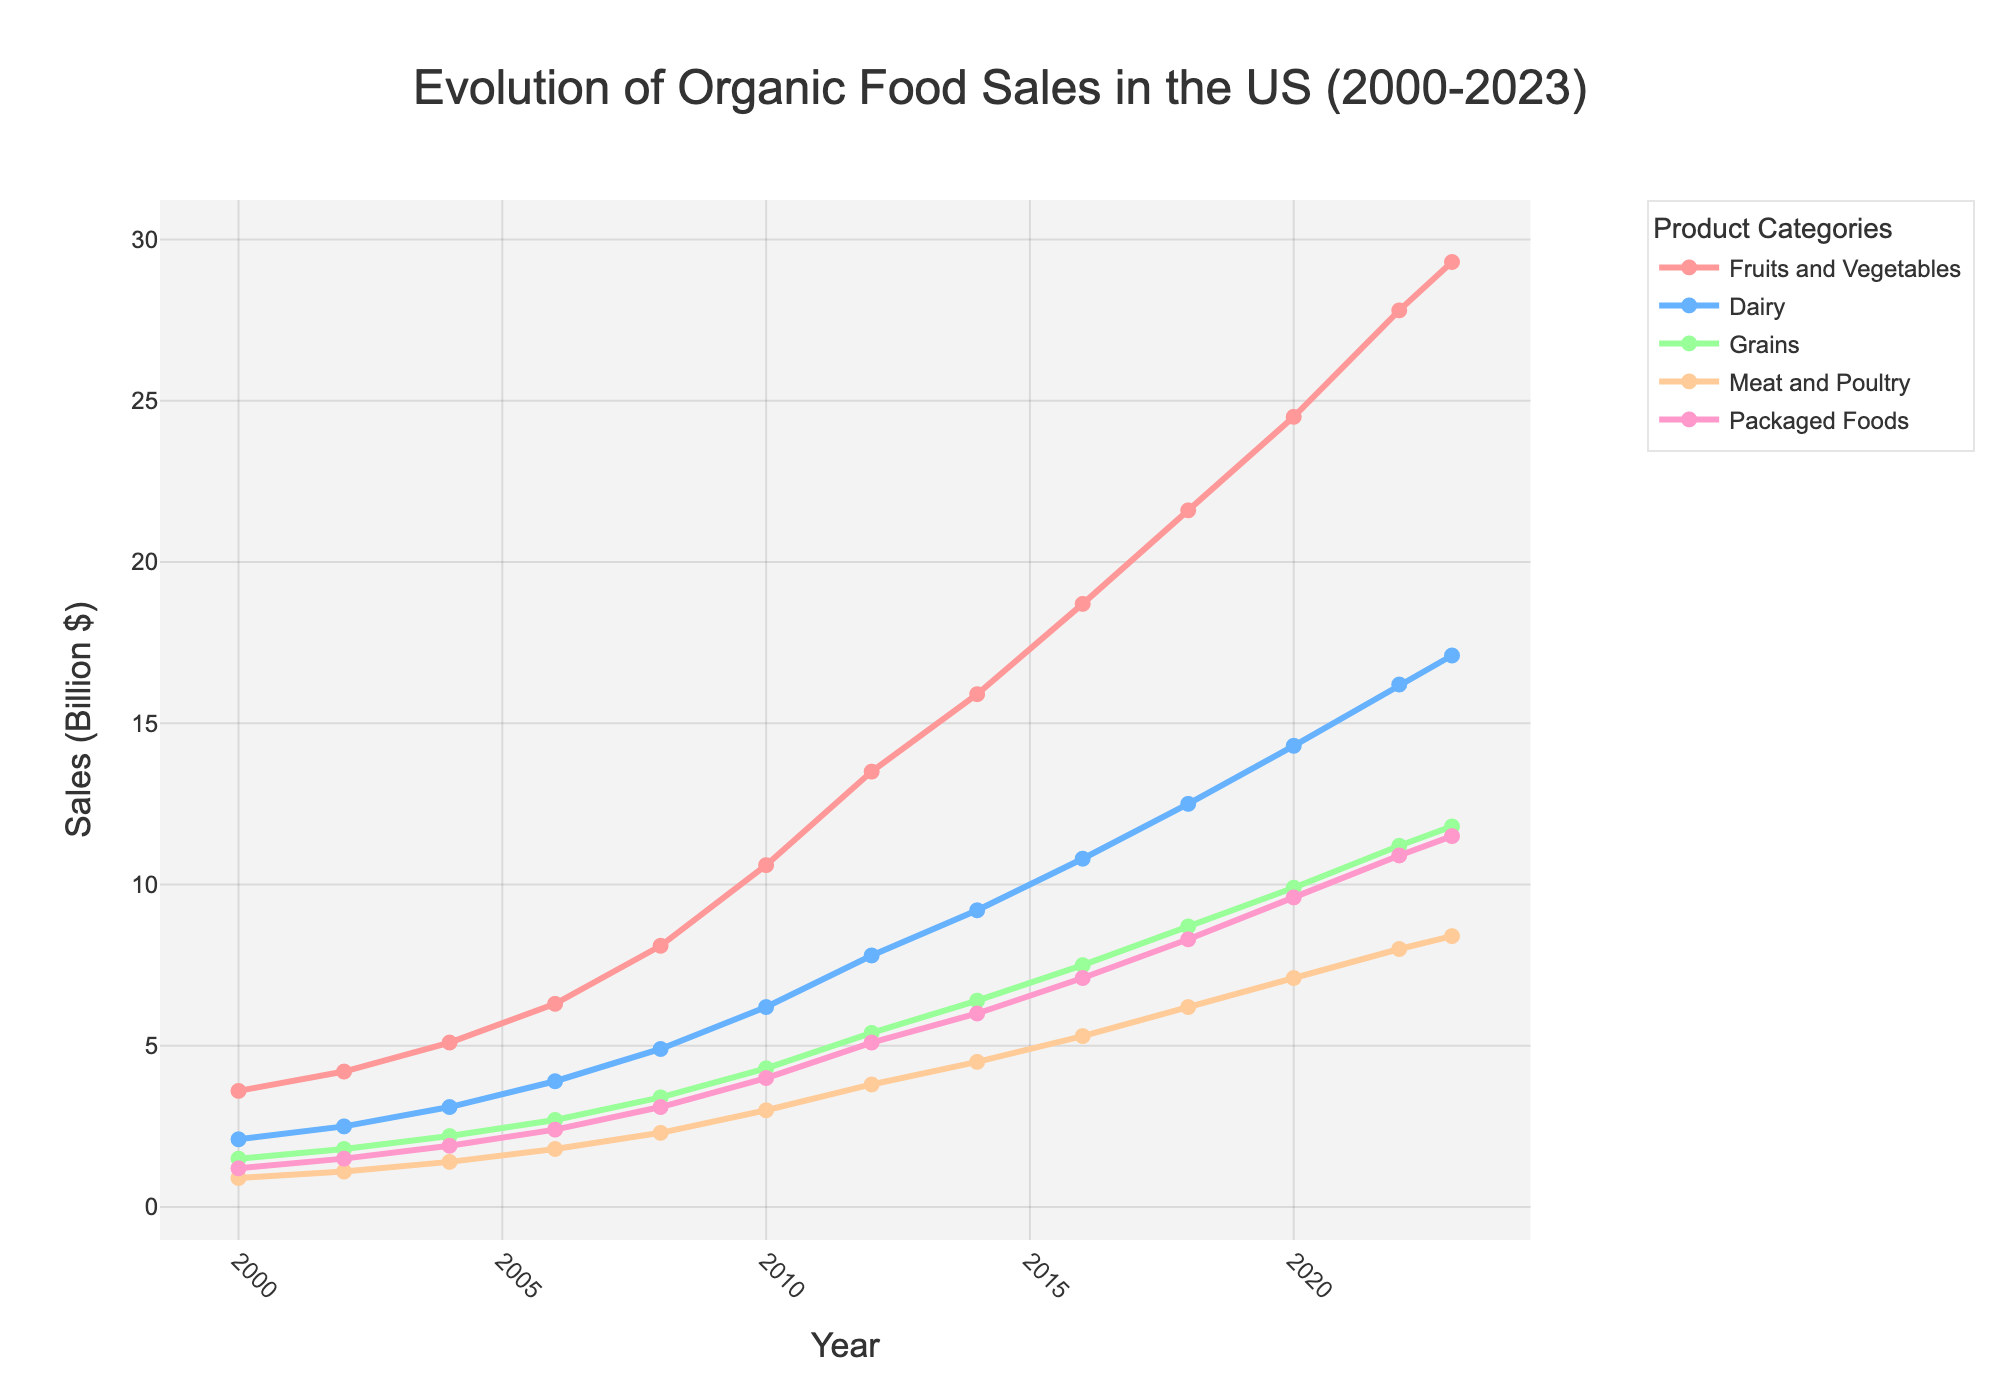what trends are noticeable for the 'Fruits and Vegetables' sales from 2000 to 2023? The sales for 'Fruits and Vegetables' show a steady increase from 2000 to 2023. Starting at $3.6 billion in 2000, they rise consistently each year, reaching $29.3 billion by 2023.
Answer: Steady increase which product category had the highest sales in 2023? By examining the values at the endpoint of each line representing the product categories, 'Fruits and Vegetables' lead with $29.3 billion in sales in 2023.
Answer: Fruits and Vegetables how did the sales of 'Meat and Poultry' change from 2010 to 2020? In 2010, 'Meat and Poultry' sales were $3.0 billion and rose steadily over the years, reaching $7.1 billion in 2020. The increase over this period is $7.1 billion - $3.0 billion = $4.1 billion.
Answer: Increased by $4.1 billion in which year did 'Packaged Foods' sales exceed $10 billion? By looking at the data points for 'Packaged Foods,' the sales exceeded $10 billion in the year 2022 with $10.9 billion.
Answer: 2022 by how much did 'Dairy' sales increase from 2008 to 2023? 'Dairy' sales were $4.9 billion in 2008 and increased to $17.1 billion in 2023. The increase is $17.1 billion - $4.9 billion = $12.2 billion.
Answer: $12.2 billion which product category had the lowest sales in 2000 and what was the value? By glancing at the data points for each category in 2000, 'Meat and Poultry' had the lowest sales with $0.9 billion.
Answer: Meat and Poultry, $0.9 billion was there any point where 'Grains' sales decreased? Observing the trend for 'Grains' over the years, there is no apparent decrease; the sales consistently increased every period.
Answer: No What is the average sales of 'Packaged Foods' from 2000 to 2023? Sum the sales for 'Packaged Foods' from 2000 to 2023, which is 1.2 + 1.5 + 1.9 + 2.4 + 3.1 + 4.0 + 5.1 + 6.0 + 7.1 + 8.3 + 9.6 + 10.9 + 11.5 = 72.6. The number of years is 13, hence the average is 72.6 / 13 ≈ 5.58 billion.
Answer: ≈ 5.58 billion 